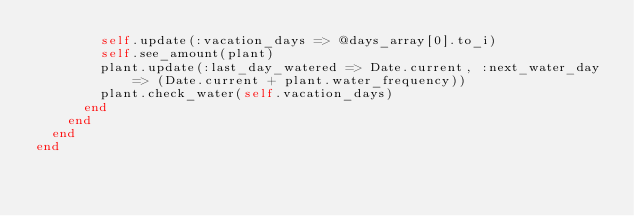<code> <loc_0><loc_0><loc_500><loc_500><_Ruby_>        self.update(:vacation_days => @days_array[0].to_i)
        self.see_amount(plant)
        plant.update(:last_day_watered => Date.current, :next_water_day => (Date.current + plant.water_frequency))
        plant.check_water(self.vacation_days)
      end
    end
  end
end
</code> 